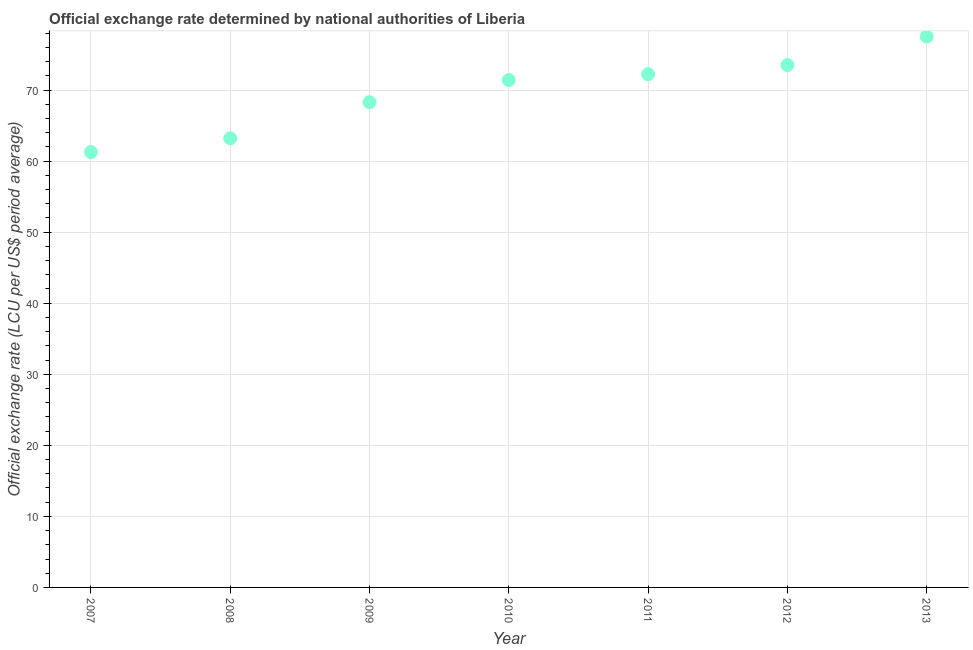What is the official exchange rate in 2012?
Your answer should be very brief. 73.51. Across all years, what is the maximum official exchange rate?
Your answer should be compact. 77.52. Across all years, what is the minimum official exchange rate?
Keep it short and to the point. 61.27. In which year was the official exchange rate maximum?
Your answer should be very brief. 2013. In which year was the official exchange rate minimum?
Give a very brief answer. 2007. What is the sum of the official exchange rate?
Your answer should be compact. 487.43. What is the difference between the official exchange rate in 2009 and 2010?
Provide a short and direct response. -3.12. What is the average official exchange rate per year?
Your response must be concise. 69.63. What is the median official exchange rate?
Offer a terse response. 71.4. In how many years, is the official exchange rate greater than 70 ?
Make the answer very short. 4. What is the ratio of the official exchange rate in 2009 to that in 2013?
Make the answer very short. 0.88. Is the official exchange rate in 2008 less than that in 2010?
Provide a succinct answer. Yes. Is the difference between the official exchange rate in 2011 and 2012 greater than the difference between any two years?
Your response must be concise. No. What is the difference between the highest and the second highest official exchange rate?
Give a very brief answer. 4.01. Is the sum of the official exchange rate in 2011 and 2012 greater than the maximum official exchange rate across all years?
Your answer should be very brief. Yes. What is the difference between the highest and the lowest official exchange rate?
Offer a terse response. 16.25. How many years are there in the graph?
Your response must be concise. 7. What is the difference between two consecutive major ticks on the Y-axis?
Your answer should be very brief. 10. Are the values on the major ticks of Y-axis written in scientific E-notation?
Make the answer very short. No. Does the graph contain any zero values?
Give a very brief answer. No. What is the title of the graph?
Offer a terse response. Official exchange rate determined by national authorities of Liberia. What is the label or title of the X-axis?
Your answer should be very brief. Year. What is the label or title of the Y-axis?
Offer a very short reply. Official exchange rate (LCU per US$ period average). What is the Official exchange rate (LCU per US$ period average) in 2007?
Offer a terse response. 61.27. What is the Official exchange rate (LCU per US$ period average) in 2008?
Your answer should be compact. 63.21. What is the Official exchange rate (LCU per US$ period average) in 2009?
Make the answer very short. 68.29. What is the Official exchange rate (LCU per US$ period average) in 2010?
Your response must be concise. 71.4. What is the Official exchange rate (LCU per US$ period average) in 2011?
Your response must be concise. 72.23. What is the Official exchange rate (LCU per US$ period average) in 2012?
Your answer should be very brief. 73.51. What is the Official exchange rate (LCU per US$ period average) in 2013?
Give a very brief answer. 77.52. What is the difference between the Official exchange rate (LCU per US$ period average) in 2007 and 2008?
Ensure brevity in your answer.  -1.94. What is the difference between the Official exchange rate (LCU per US$ period average) in 2007 and 2009?
Offer a terse response. -7.01. What is the difference between the Official exchange rate (LCU per US$ period average) in 2007 and 2010?
Provide a succinct answer. -10.13. What is the difference between the Official exchange rate (LCU per US$ period average) in 2007 and 2011?
Keep it short and to the point. -10.95. What is the difference between the Official exchange rate (LCU per US$ period average) in 2007 and 2012?
Offer a terse response. -12.24. What is the difference between the Official exchange rate (LCU per US$ period average) in 2007 and 2013?
Provide a short and direct response. -16.25. What is the difference between the Official exchange rate (LCU per US$ period average) in 2008 and 2009?
Provide a short and direct response. -5.08. What is the difference between the Official exchange rate (LCU per US$ period average) in 2008 and 2010?
Provide a succinct answer. -8.2. What is the difference between the Official exchange rate (LCU per US$ period average) in 2008 and 2011?
Your answer should be compact. -9.02. What is the difference between the Official exchange rate (LCU per US$ period average) in 2008 and 2012?
Your answer should be very brief. -10.31. What is the difference between the Official exchange rate (LCU per US$ period average) in 2008 and 2013?
Offer a very short reply. -14.31. What is the difference between the Official exchange rate (LCU per US$ period average) in 2009 and 2010?
Keep it short and to the point. -3.12. What is the difference between the Official exchange rate (LCU per US$ period average) in 2009 and 2011?
Your response must be concise. -3.94. What is the difference between the Official exchange rate (LCU per US$ period average) in 2009 and 2012?
Give a very brief answer. -5.23. What is the difference between the Official exchange rate (LCU per US$ period average) in 2009 and 2013?
Your answer should be very brief. -9.23. What is the difference between the Official exchange rate (LCU per US$ period average) in 2010 and 2011?
Give a very brief answer. -0.82. What is the difference between the Official exchange rate (LCU per US$ period average) in 2010 and 2012?
Offer a terse response. -2.11. What is the difference between the Official exchange rate (LCU per US$ period average) in 2010 and 2013?
Your response must be concise. -6.12. What is the difference between the Official exchange rate (LCU per US$ period average) in 2011 and 2012?
Your response must be concise. -1.29. What is the difference between the Official exchange rate (LCU per US$ period average) in 2011 and 2013?
Your response must be concise. -5.29. What is the difference between the Official exchange rate (LCU per US$ period average) in 2012 and 2013?
Give a very brief answer. -4.01. What is the ratio of the Official exchange rate (LCU per US$ period average) in 2007 to that in 2008?
Your response must be concise. 0.97. What is the ratio of the Official exchange rate (LCU per US$ period average) in 2007 to that in 2009?
Provide a succinct answer. 0.9. What is the ratio of the Official exchange rate (LCU per US$ period average) in 2007 to that in 2010?
Make the answer very short. 0.86. What is the ratio of the Official exchange rate (LCU per US$ period average) in 2007 to that in 2011?
Your answer should be compact. 0.85. What is the ratio of the Official exchange rate (LCU per US$ period average) in 2007 to that in 2012?
Give a very brief answer. 0.83. What is the ratio of the Official exchange rate (LCU per US$ period average) in 2007 to that in 2013?
Provide a short and direct response. 0.79. What is the ratio of the Official exchange rate (LCU per US$ period average) in 2008 to that in 2009?
Provide a short and direct response. 0.93. What is the ratio of the Official exchange rate (LCU per US$ period average) in 2008 to that in 2010?
Offer a terse response. 0.89. What is the ratio of the Official exchange rate (LCU per US$ period average) in 2008 to that in 2012?
Offer a very short reply. 0.86. What is the ratio of the Official exchange rate (LCU per US$ period average) in 2008 to that in 2013?
Offer a terse response. 0.81. What is the ratio of the Official exchange rate (LCU per US$ period average) in 2009 to that in 2010?
Offer a terse response. 0.96. What is the ratio of the Official exchange rate (LCU per US$ period average) in 2009 to that in 2011?
Offer a terse response. 0.94. What is the ratio of the Official exchange rate (LCU per US$ period average) in 2009 to that in 2012?
Your response must be concise. 0.93. What is the ratio of the Official exchange rate (LCU per US$ period average) in 2009 to that in 2013?
Your response must be concise. 0.88. What is the ratio of the Official exchange rate (LCU per US$ period average) in 2010 to that in 2011?
Offer a very short reply. 0.99. What is the ratio of the Official exchange rate (LCU per US$ period average) in 2010 to that in 2012?
Your answer should be very brief. 0.97. What is the ratio of the Official exchange rate (LCU per US$ period average) in 2010 to that in 2013?
Your answer should be compact. 0.92. What is the ratio of the Official exchange rate (LCU per US$ period average) in 2011 to that in 2013?
Make the answer very short. 0.93. What is the ratio of the Official exchange rate (LCU per US$ period average) in 2012 to that in 2013?
Offer a terse response. 0.95. 